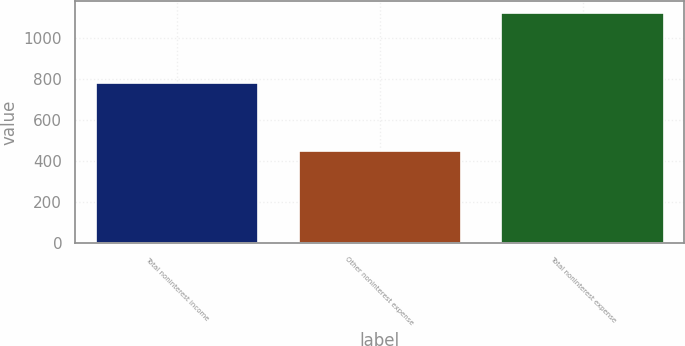Convert chart. <chart><loc_0><loc_0><loc_500><loc_500><bar_chart><fcel>Total noninterest income<fcel>Other noninterest expense<fcel>Total noninterest expense<nl><fcel>778<fcel>450<fcel>1122<nl></chart> 